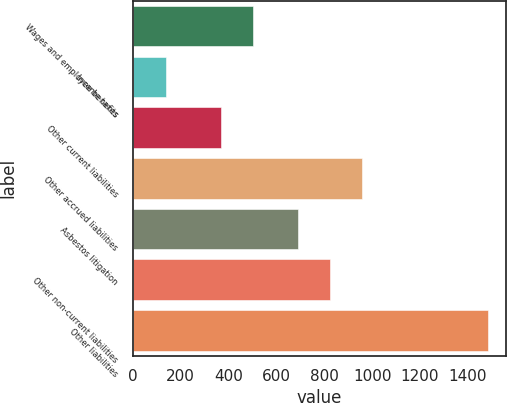Convert chart. <chart><loc_0><loc_0><loc_500><loc_500><bar_chart><fcel>Wages and employee benefits<fcel>Income taxes<fcel>Other current liabilities<fcel>Other accrued liabilities<fcel>Asbestos litigation<fcel>Other non-current liabilities<fcel>Other liabilities<nl><fcel>504.4<fcel>139<fcel>370<fcel>958.8<fcel>690<fcel>824.4<fcel>1483<nl></chart> 